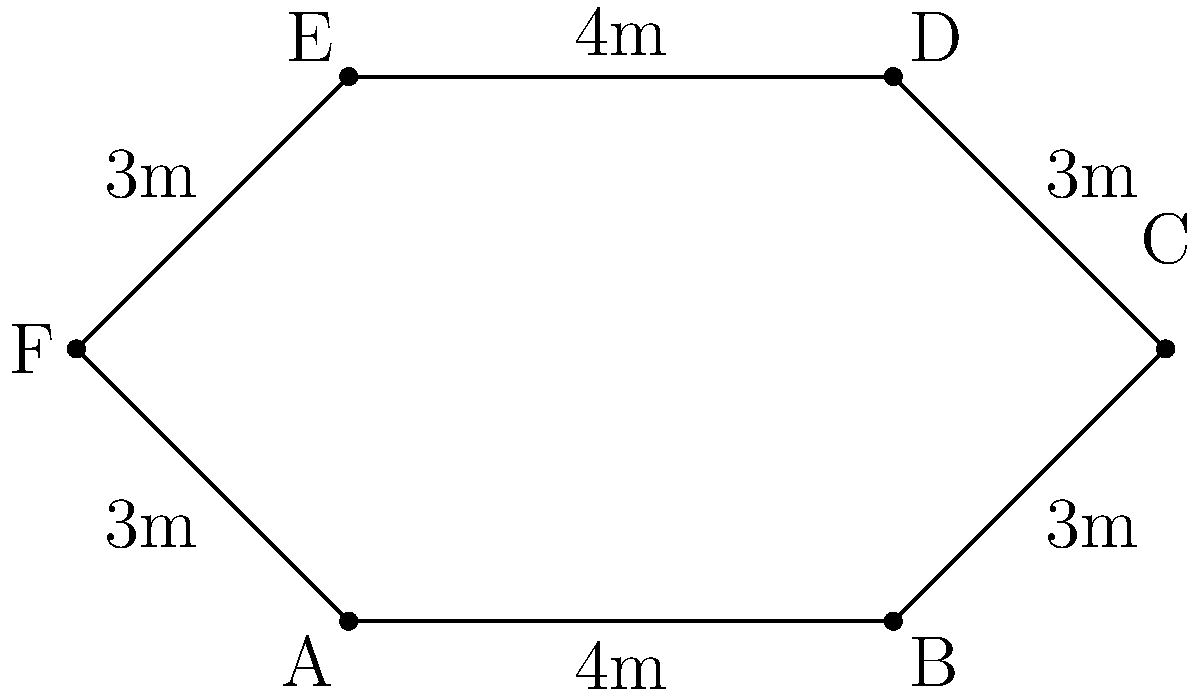For your child's sensory garden, you want to create a butterfly-shaped garden bed. The shape is made up of six segments as shown in the diagram. Calculate the perimeter of the garden bed. To calculate the perimeter of the butterfly-shaped garden bed, we need to add up the lengths of all six segments:

1. Segment AB: 4m
2. Segment BC: 3m
3. Segment CD: 3m
4. Segment DE: 4m
5. Segment EF: 3m
6. Segment FA: 3m

Total perimeter = AB + BC + CD + DE + EF + FA
                = 4m + 3m + 3m + 4m + 3m + 3m
                = 20m

Therefore, the perimeter of the butterfly-shaped garden bed is 20 meters.
Answer: 20m 